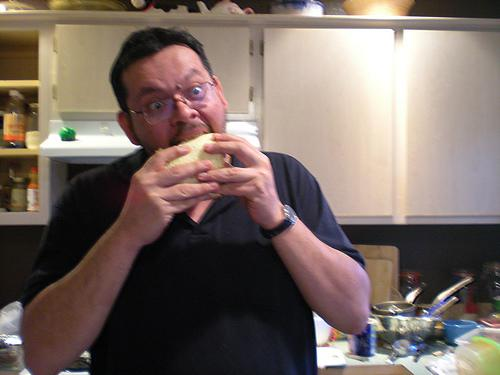Question: when was the pic taken?
Choices:
A. At night.
B. The morning.
C. At sunrise.
D. At sunset.
Answer with the letter. Answer: A Question: what is he doing?
Choices:
A. Swimming.
B. Running.
C. Walking.
D. Eating.
Answer with the letter. Answer: D Question: what is the color of his shirt?
Choices:
A. White.
B. Red.
C. Blue.
D. Black.
Answer with the letter. Answer: D Question: what is he wearing?
Choices:
A. A hat.
B. A suit.
C. Glasses.
D. Sunglasses.
Answer with the letter. Answer: C 